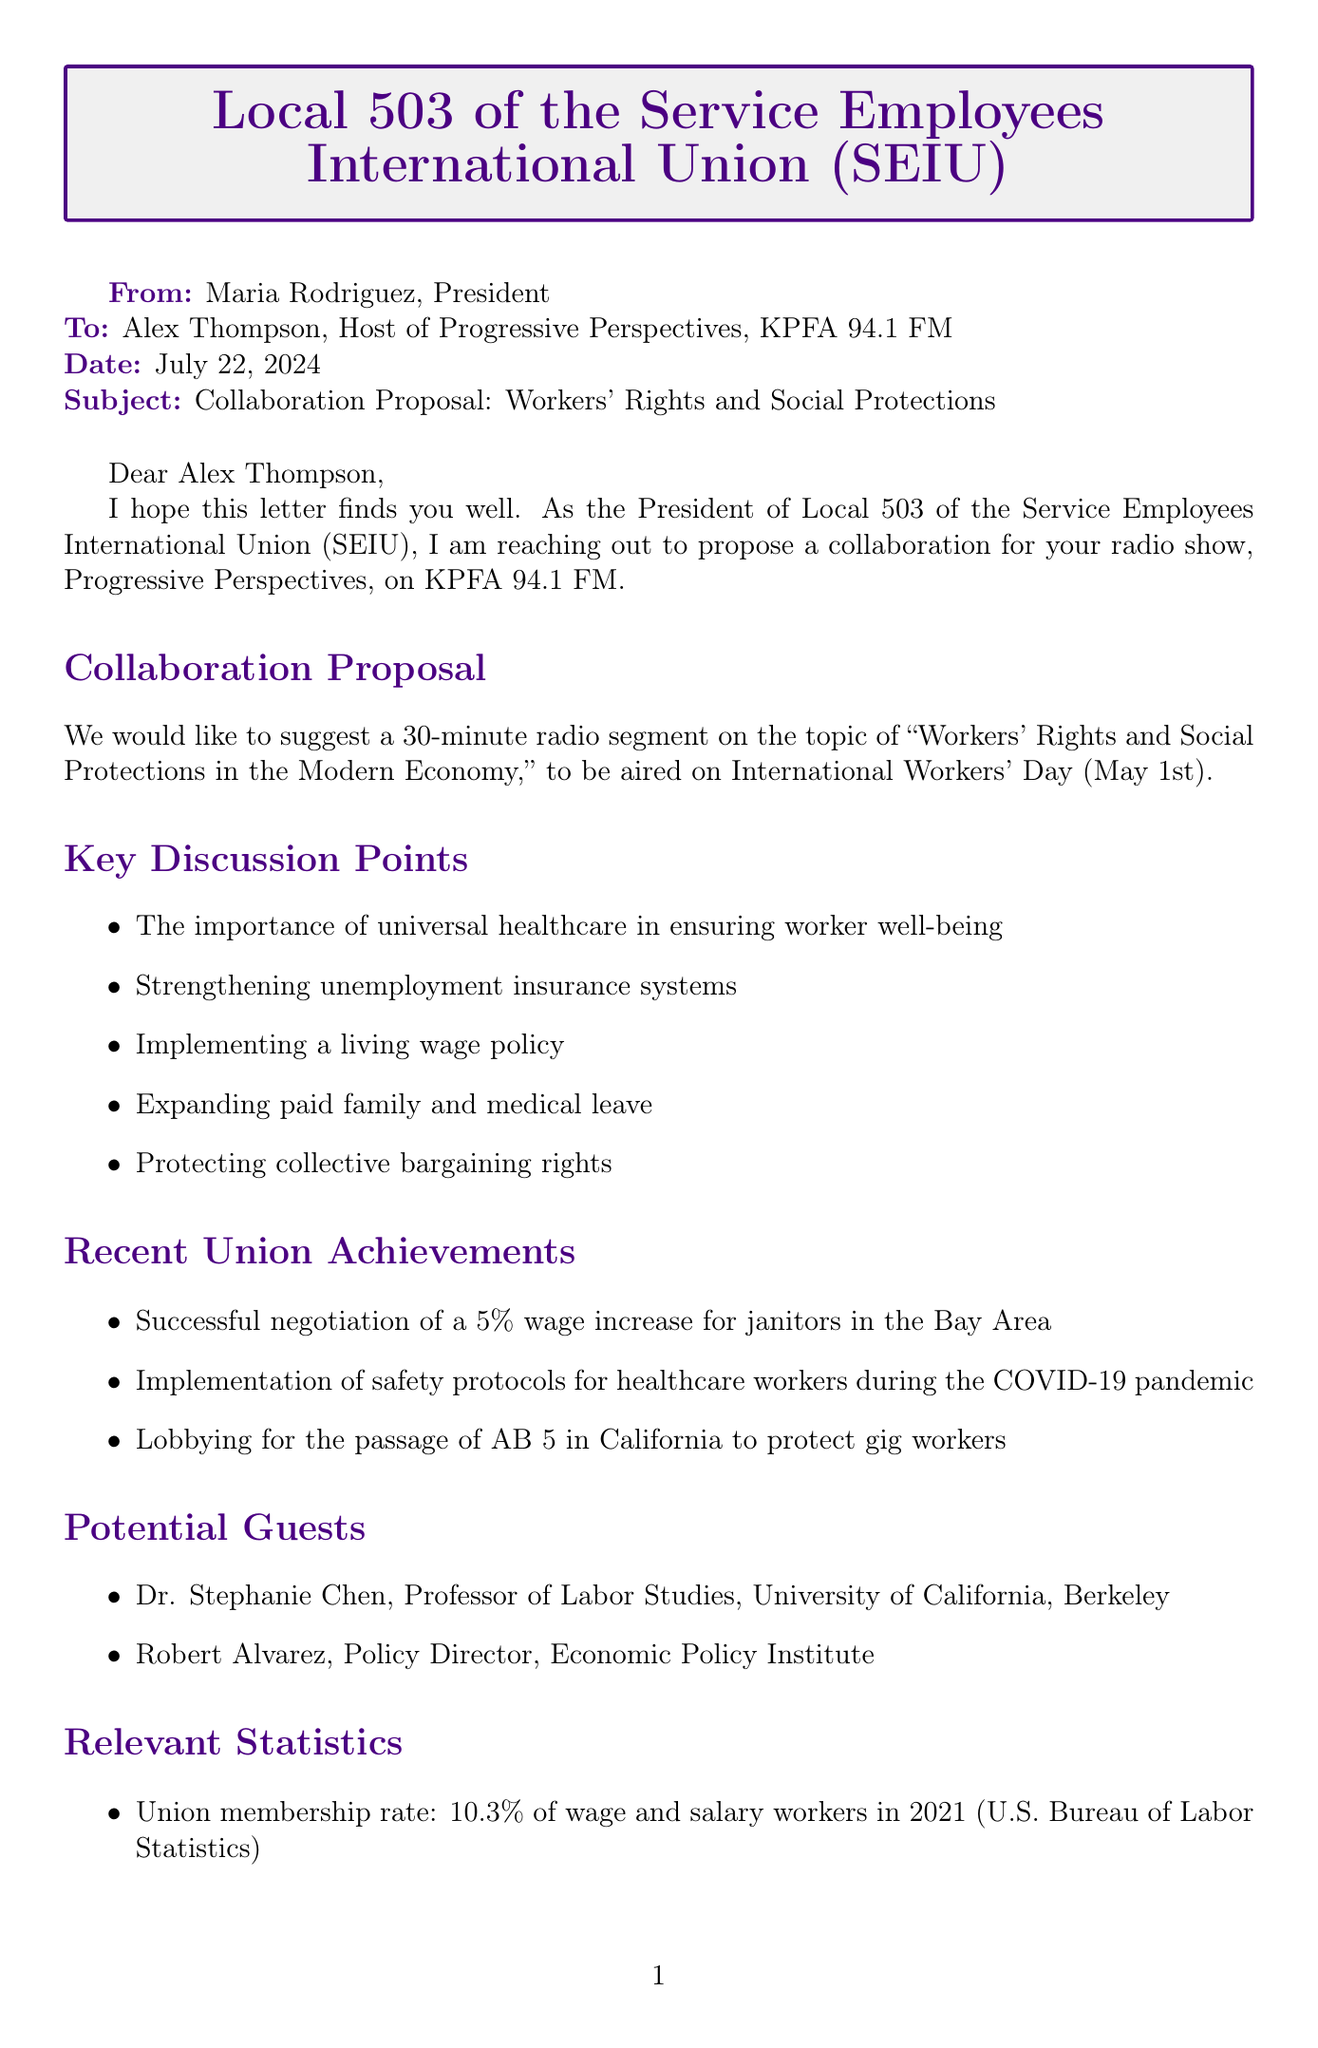What is the sender's name? The sender's name is explicitly mentioned at the beginning of the letter as Maria Rodriguez.
Answer: Maria Rodriguez What is the topic proposed for the radio segment? The topic is clearly stated in the collaboration proposal section as "Workers' Rights and Social Protections in the Modern Economy."
Answer: Workers' Rights and Social Protections in the Modern Economy When is the proposed date for the radio segment? The proposed date is mentioned in the collaboration proposal section, which states it will be aired on International Workers' Day (May 1st).
Answer: International Workers' Day (May 1st) What percentage of wage and salary workers were union members in 2021? The union membership rate in the relevant statistics section is specified as 10.3%.
Answer: 10.3% What recent achievement involved a wage increase? One of the recent union achievements listed is "Successful negotiation of a 5% wage increase for janitors in the Bay Area."
Answer: 5% Who is one of the potential guests proposed for the segment? The document lists potential guests, including Dr. Stephanie Chen as one of them.
Answer: Dr. Stephanie Chen What call to action is suggested for listeners? The document suggests that listeners should be encouraged to contact their representatives in support of the PRO Act.
Answer: Contact their representatives in support of the PRO Act What is one of the key discussion points in the segment? The letter lists several key discussion points, including the importance of universal healthcare, making it a notable aspect of the proposal.
Answer: Importance of universal healthcare What appreciation is expressed at the end of the letter? The closing remarks include an expression of gratitude for the opportunity to discuss crucial issues on the platform.
Answer: Appreciation for the platform to discuss these crucial issues 